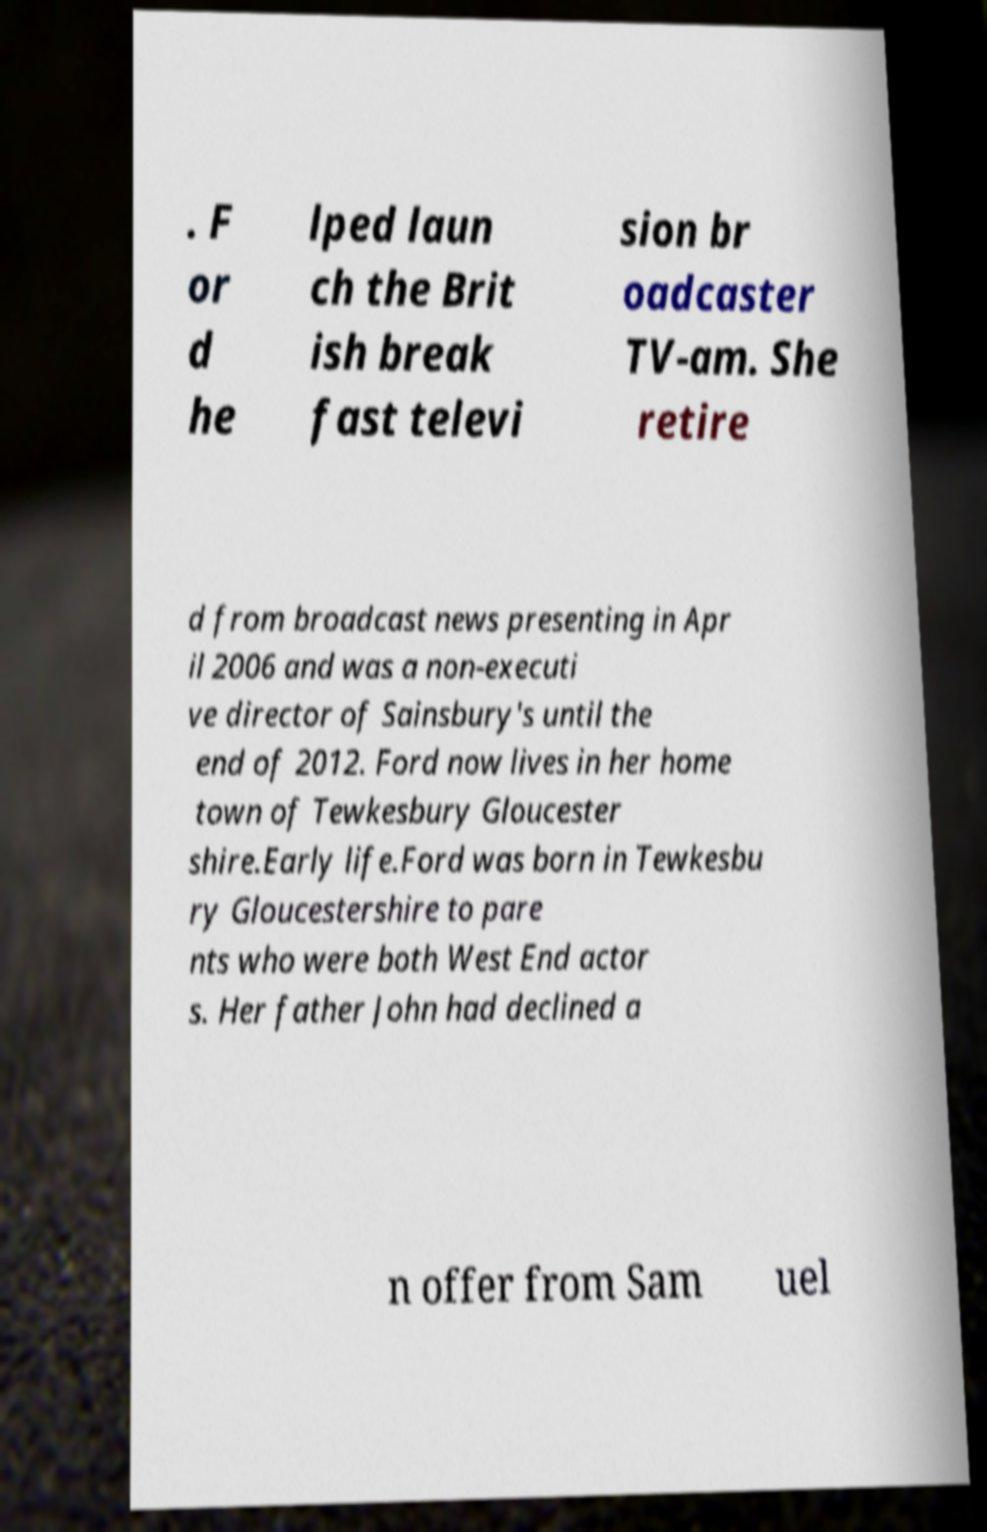For documentation purposes, I need the text within this image transcribed. Could you provide that? . F or d he lped laun ch the Brit ish break fast televi sion br oadcaster TV-am. She retire d from broadcast news presenting in Apr il 2006 and was a non-executi ve director of Sainsbury's until the end of 2012. Ford now lives in her home town of Tewkesbury Gloucester shire.Early life.Ford was born in Tewkesbu ry Gloucestershire to pare nts who were both West End actor s. Her father John had declined a n offer from Sam uel 